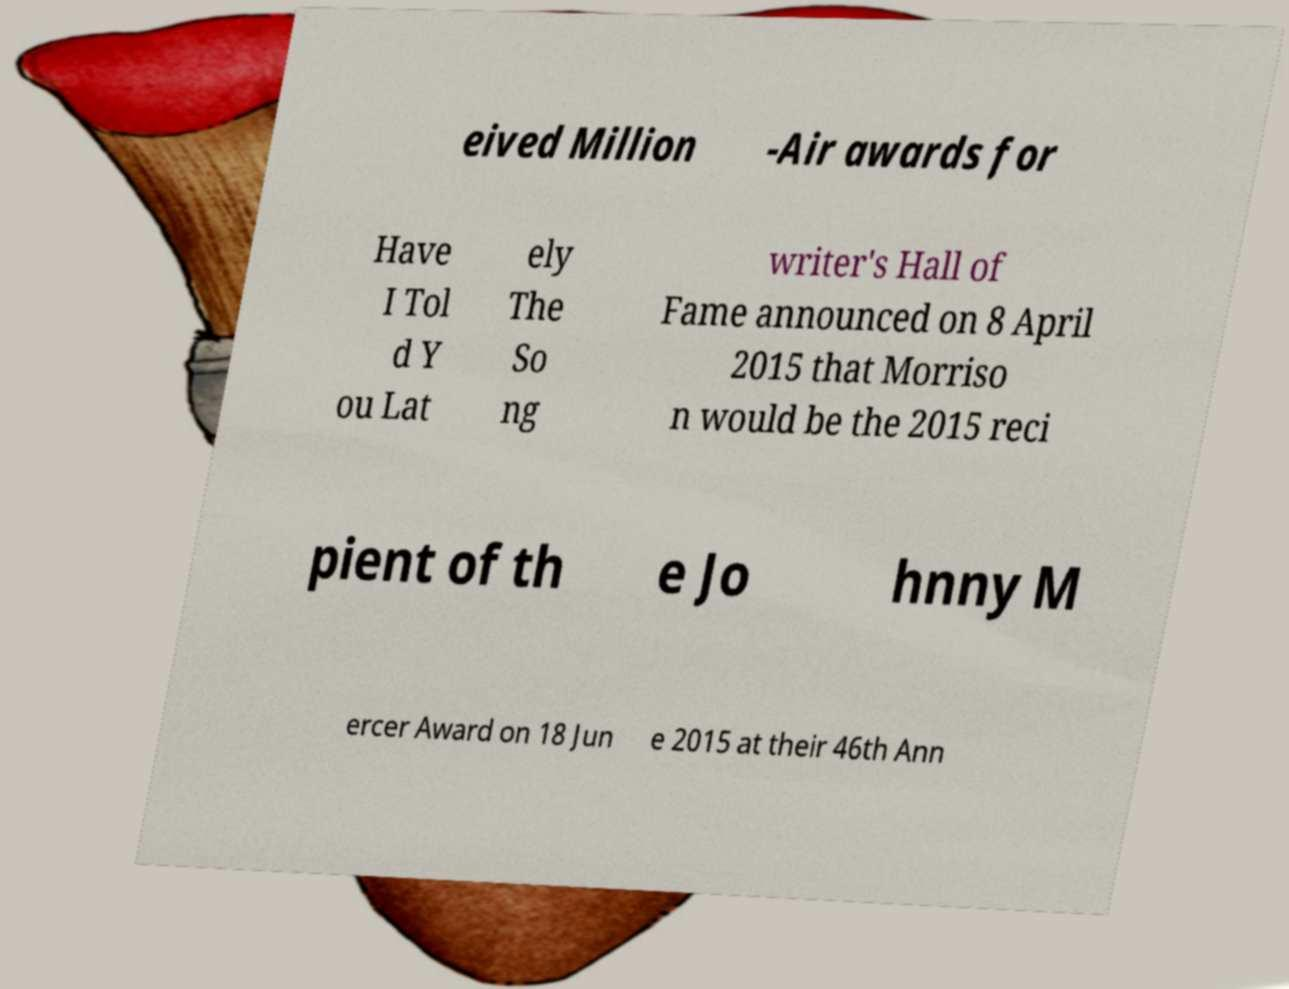Could you extract and type out the text from this image? eived Million -Air awards for Have I Tol d Y ou Lat ely The So ng writer's Hall of Fame announced on 8 April 2015 that Morriso n would be the 2015 reci pient of th e Jo hnny M ercer Award on 18 Jun e 2015 at their 46th Ann 